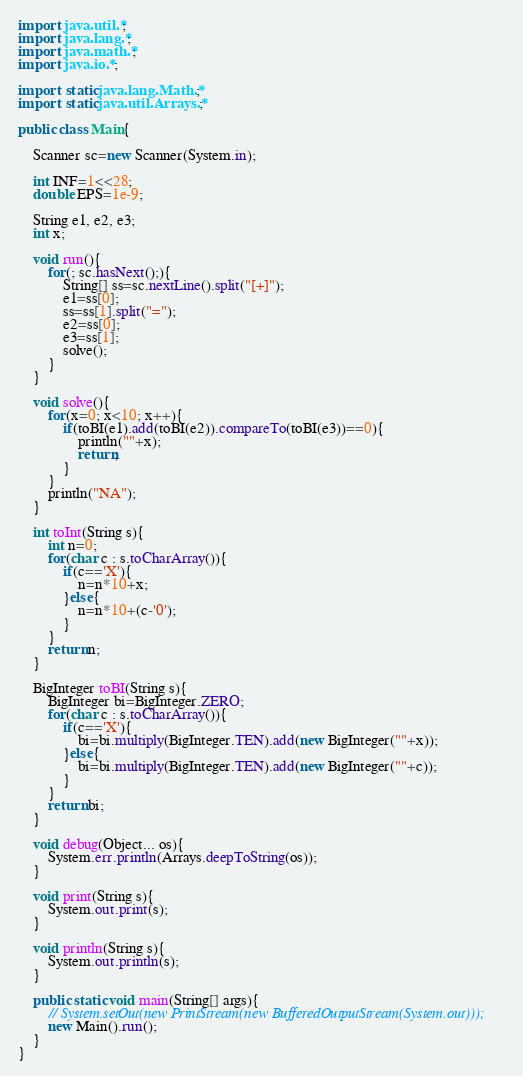Convert code to text. <code><loc_0><loc_0><loc_500><loc_500><_Java_>import java.util.*;
import java.lang.*;
import java.math.*;
import java.io.*;

import static java.lang.Math.*;
import static java.util.Arrays.*;

public class Main{

	Scanner sc=new Scanner(System.in);

	int INF=1<<28;
	double EPS=1e-9;

	String e1, e2, e3;
	int x;

	void run(){
		for(; sc.hasNext();){
			String[] ss=sc.nextLine().split("[+]");
			e1=ss[0];
			ss=ss[1].split("=");
			e2=ss[0];
			e3=ss[1];
			solve();
		}
	}

	void solve(){
		for(x=0; x<10; x++){
			if(toBI(e1).add(toBI(e2)).compareTo(toBI(e3))==0){
				println(""+x);
				return;
			}
		}
		println("NA");
	}

	int toInt(String s){
		int n=0;
		for(char c : s.toCharArray()){
			if(c=='X'){
				n=n*10+x;
			}else{
				n=n*10+(c-'0');
			}
		}
		return n;
	}

	BigInteger toBI(String s){
		BigInteger bi=BigInteger.ZERO;
		for(char c : s.toCharArray()){
			if(c=='X'){
				bi=bi.multiply(BigInteger.TEN).add(new BigInteger(""+x));
			}else{
				bi=bi.multiply(BigInteger.TEN).add(new BigInteger(""+c));
			}
		}
		return bi;
	}

	void debug(Object... os){
		System.err.println(Arrays.deepToString(os));
	}

	void print(String s){
		System.out.print(s);
	}

	void println(String s){
		System.out.println(s);
	}

	public static void main(String[] args){
		// System.setOut(new PrintStream(new BufferedOutputStream(System.out)));
		new Main().run();
	}
}</code> 